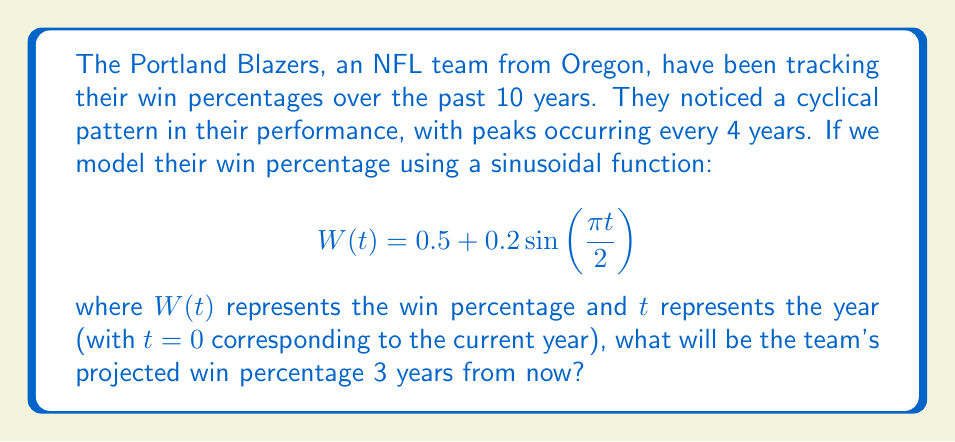Show me your answer to this math problem. To solve this problem, we need to follow these steps:

1) We're given the sinusoidal function:
   $$W(t) = 0.5 + 0.2\sin\left(\frac{\pi t}{2}\right)$$

2) We need to find $W(3)$ since we're interested in the win percentage 3 years from now.

3) Let's substitute $t=3$ into the equation:

   $$W(3) = 0.5 + 0.2\sin\left(\frac{\pi (3)}{2}\right)$$

4) Simplify the argument of the sine function:

   $$W(3) = 0.5 + 0.2\sin\left(\frac{3\pi}{2}\right)$$

5) Recall that $\sin(\frac{3\pi}{2}) = -1$

6) Substitute this value:

   $$W(3) = 0.5 + 0.2(-1)$$

7) Simplify:

   $$W(3) = 0.5 - 0.2 = 0.3$$

Therefore, the projected win percentage 3 years from now is 0.3 or 30%.
Answer: $0.3$ or $30\%$ 